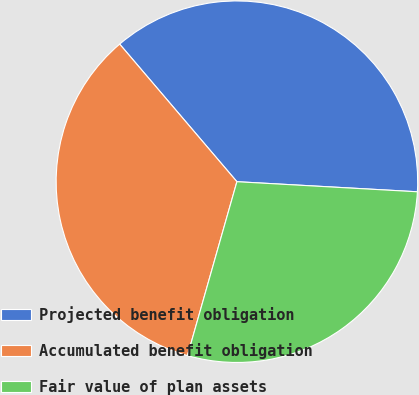Convert chart to OTSL. <chart><loc_0><loc_0><loc_500><loc_500><pie_chart><fcel>Projected benefit obligation<fcel>Accumulated benefit obligation<fcel>Fair value of plan assets<nl><fcel>37.12%<fcel>34.36%<fcel>28.52%<nl></chart> 